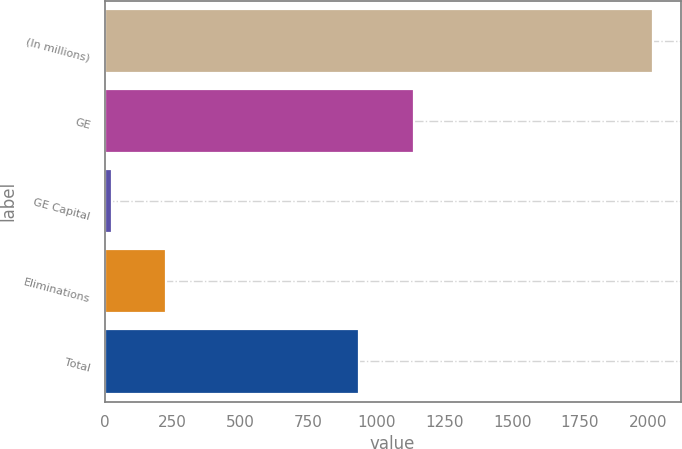Convert chart. <chart><loc_0><loc_0><loc_500><loc_500><bar_chart><fcel>(In millions)<fcel>GE<fcel>GE Capital<fcel>Eliminations<fcel>Total<nl><fcel>2020<fcel>1137.3<fcel>27<fcel>226.3<fcel>938<nl></chart> 